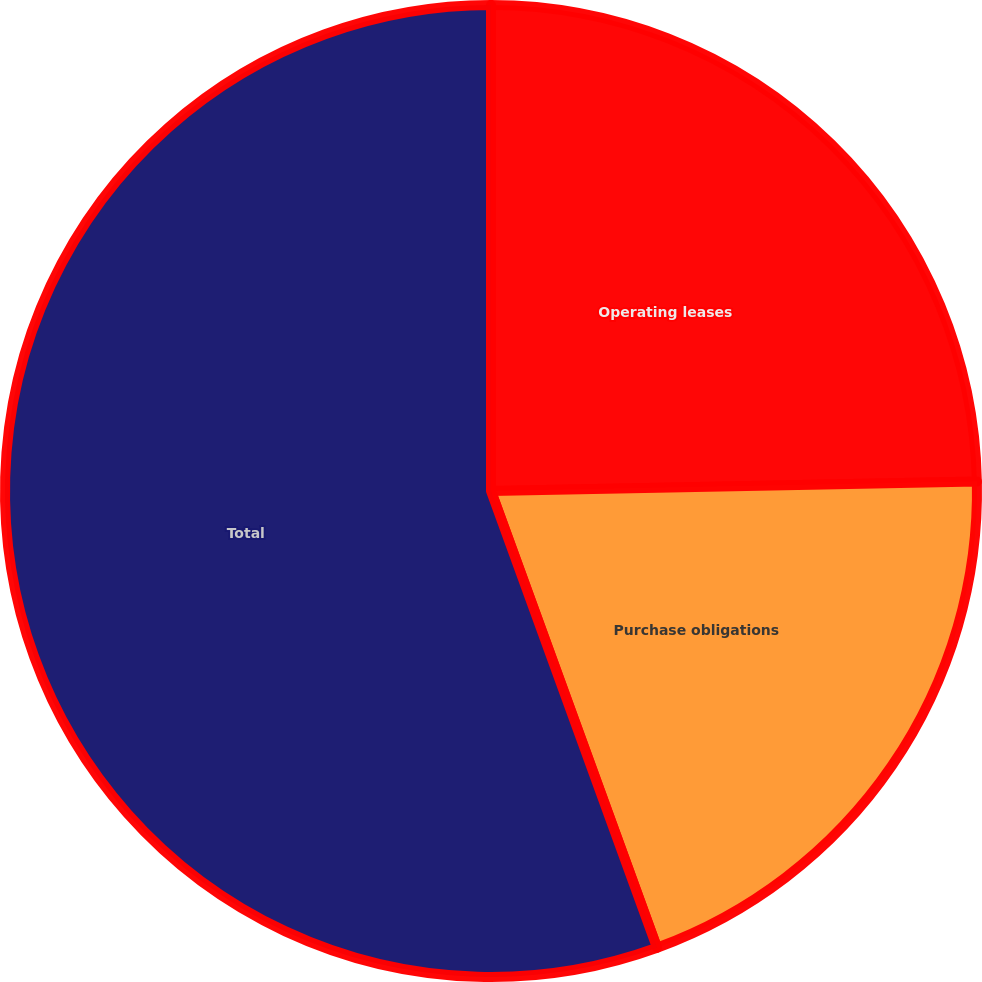Convert chart. <chart><loc_0><loc_0><loc_500><loc_500><pie_chart><fcel>Operating leases<fcel>Purchase obligations<fcel>Total<nl><fcel>24.69%<fcel>19.76%<fcel>55.55%<nl></chart> 